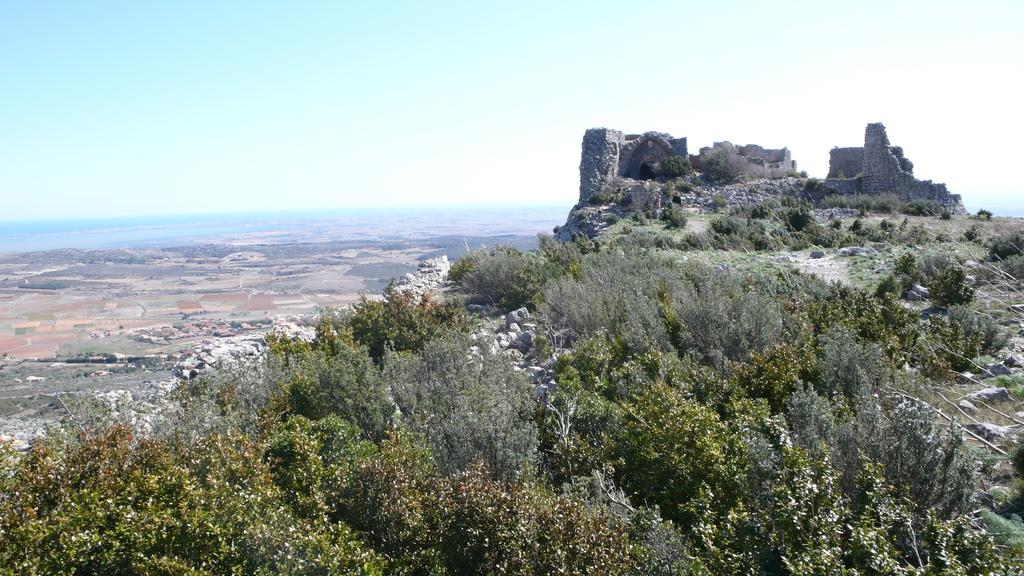What type of natural elements can be seen in the image? There are trees and plants in the image. What other objects can be seen in the image? There are rocks in the image. What is visible in the background of the image? The sky is visible in the background of the image. What type of birthday celebration is taking place in the image? There is no indication of a birthday celebration in the image; it features trees, plants, rocks, and the sky. 